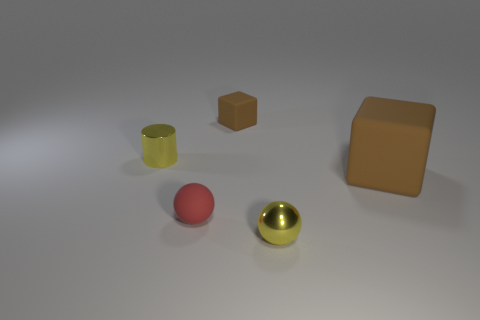Add 3 tiny metallic balls. How many tiny metallic balls are left? 4 Add 3 brown objects. How many brown objects exist? 5 Add 3 big brown matte spheres. How many objects exist? 8 Subtract all yellow spheres. How many spheres are left? 1 Subtract 0 red cylinders. How many objects are left? 5 Subtract all spheres. How many objects are left? 3 Subtract 1 cylinders. How many cylinders are left? 0 Subtract all yellow balls. Subtract all red cylinders. How many balls are left? 1 Subtract all purple blocks. How many yellow spheres are left? 1 Subtract all brown matte blocks. Subtract all large yellow blocks. How many objects are left? 3 